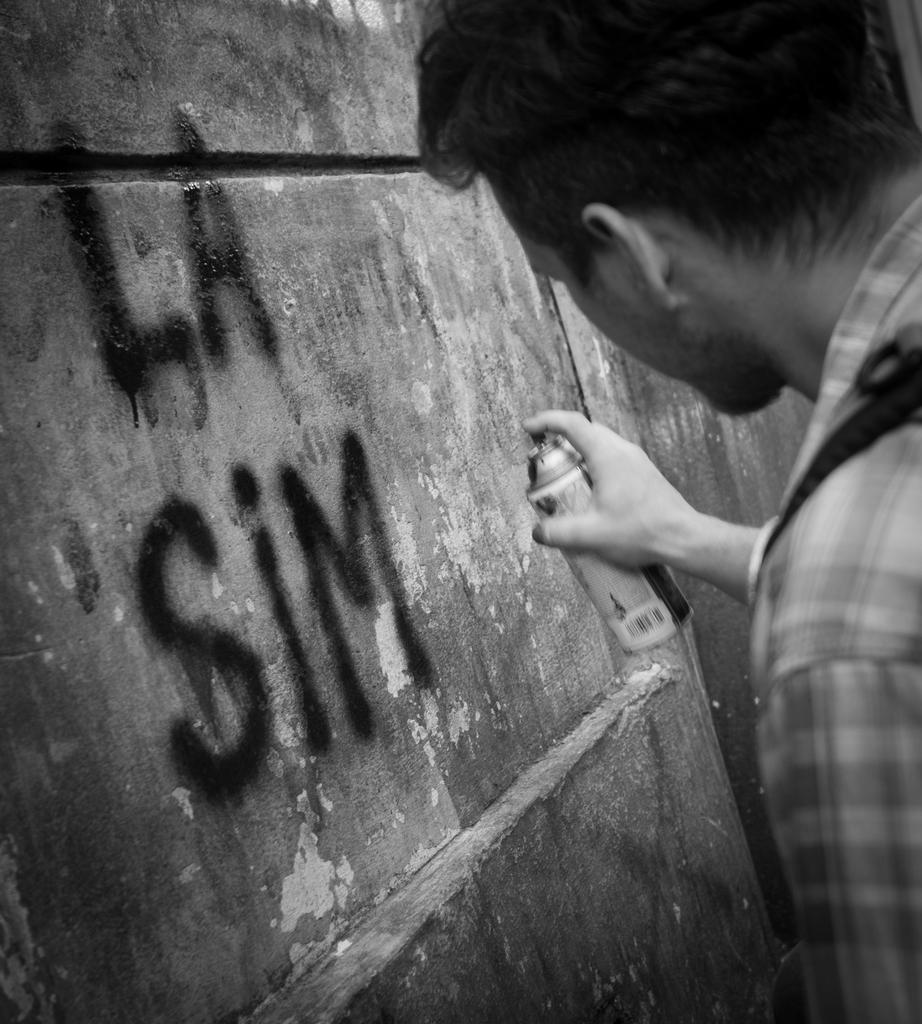What is the color scheme of the image? The image is black and white. What is depicted in the image? There is a picture of a person in the image. What is the person in the picture holding? The person in the picture is holding a bottle. What is visible in the background of the image? There is a wall in the image. What is written or displayed on the wall? There is text on the wall. Can you see any clouds in the image? There are no clouds visible in the image, as it is black and white and does not depict an outdoor scene. What type of tax is being discussed in the text on the wall? There is no mention of tax in the image, as the text on the wall is not described in detail. 